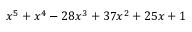<formula> <loc_0><loc_0><loc_500><loc_500>x ^ { 5 } + x ^ { 4 } - 2 8 x ^ { 3 } + 3 7 x ^ { 2 } + 2 5 x + 1</formula> 